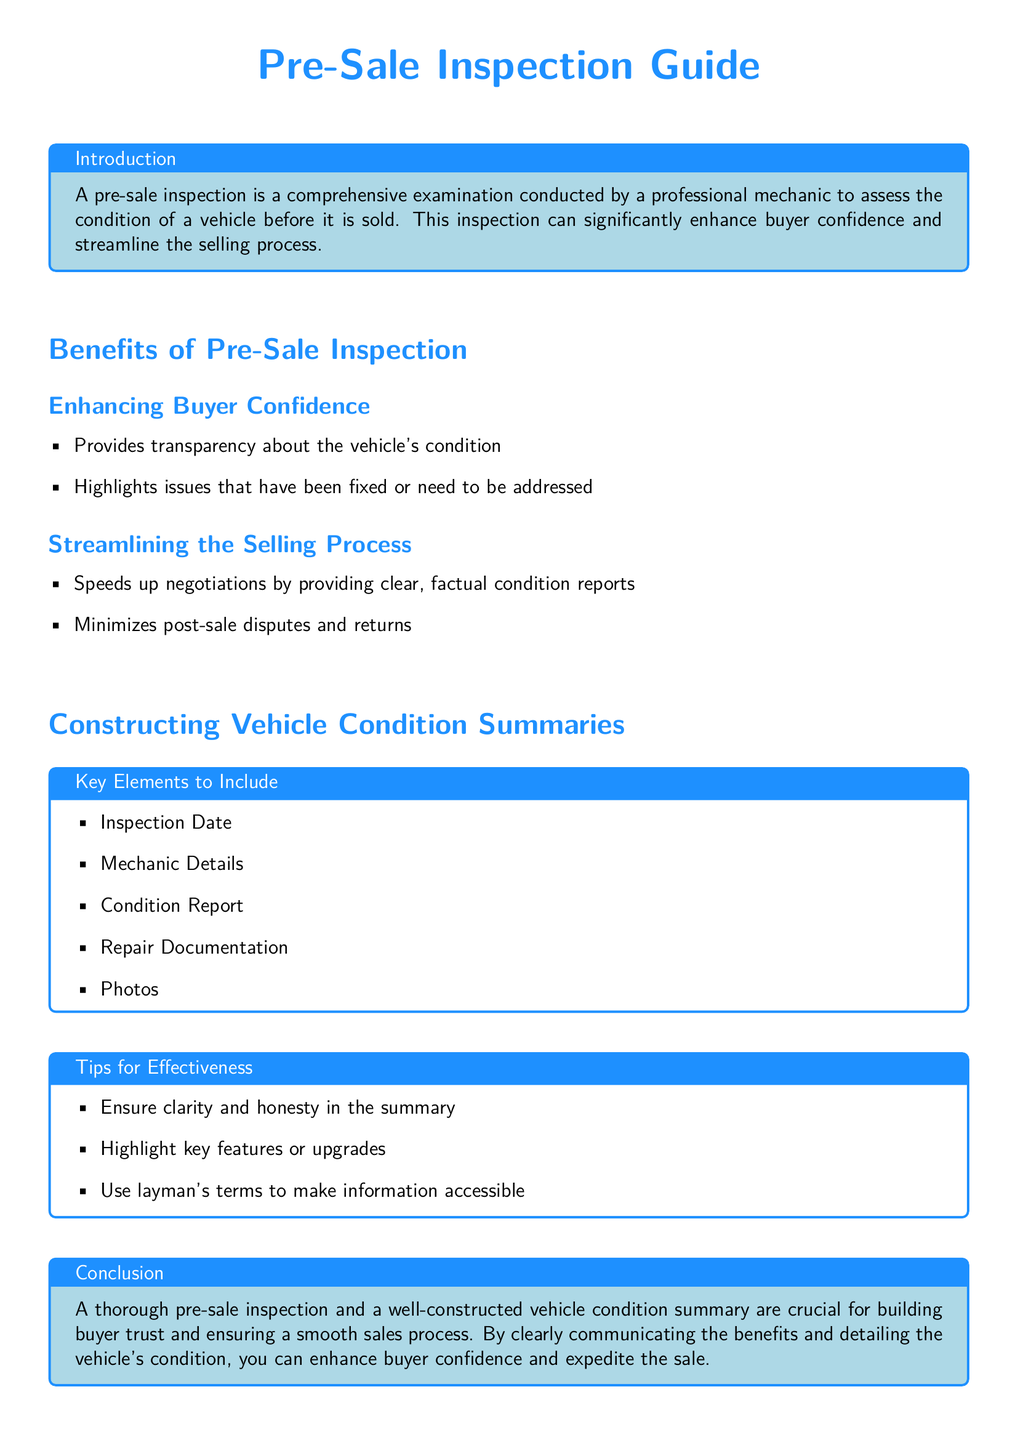What is the primary purpose of a pre-sale inspection? The primary purpose of a pre-sale inspection is to conduct a comprehensive examination of a vehicle's condition prior to selling it.
Answer: comprehensive examination What are the key benefits of conducting a pre-sale inspection? The document lists two main benefits: enhancing buyer confidence and streamlining the selling process.
Answer: enhancing buyer confidence and streamlining the selling process What should be included in a vehicle condition summary? The document outlines key elements such as inspection date, mechanic details, condition report, repair documentation, and photos.
Answer: inspection date, mechanic details, condition report, repair documentation, photos What is one tip for creating an effective vehicle condition summary? The document suggests ensuring clarity and honesty in the summary as a tip for effectiveness.
Answer: clarity and honesty Who performs the pre-sale inspection? The inspection is conducted by a professional mechanic.
Answer: professional mechanic How does a pre-sale inspection minimize potential issues? It minimizes post-sale disputes and returns by providing clear, factual condition reports.
Answer: minimizes post-sale disputes and returns What date should be included in the vehicle condition summary? The inspection date should be included in the vehicle condition summary.
Answer: inspection date What color is used for the conclusion section title? The conclusion section title is in the color defined as cardealer.
Answer: cardealer 